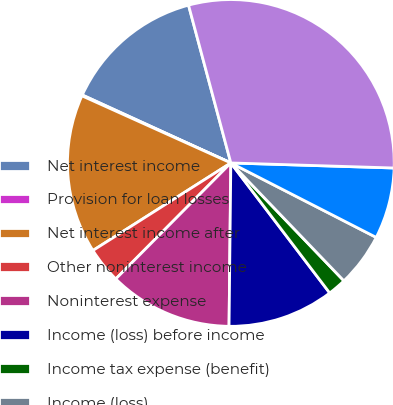Convert chart to OTSL. <chart><loc_0><loc_0><loc_500><loc_500><pie_chart><fcel>Net interest income<fcel>Provision for loan losses<fcel>Net interest income after<fcel>Other noninterest income<fcel>Noninterest expense<fcel>Income (loss) before income<fcel>Income tax expense (benefit)<fcel>Income (loss)<fcel>Net income (loss) applicable<fcel>Total assets<nl><fcel>14.0%<fcel>0.09%<fcel>15.74%<fcel>3.56%<fcel>12.26%<fcel>10.52%<fcel>1.82%<fcel>5.3%<fcel>7.04%<fcel>29.66%<nl></chart> 